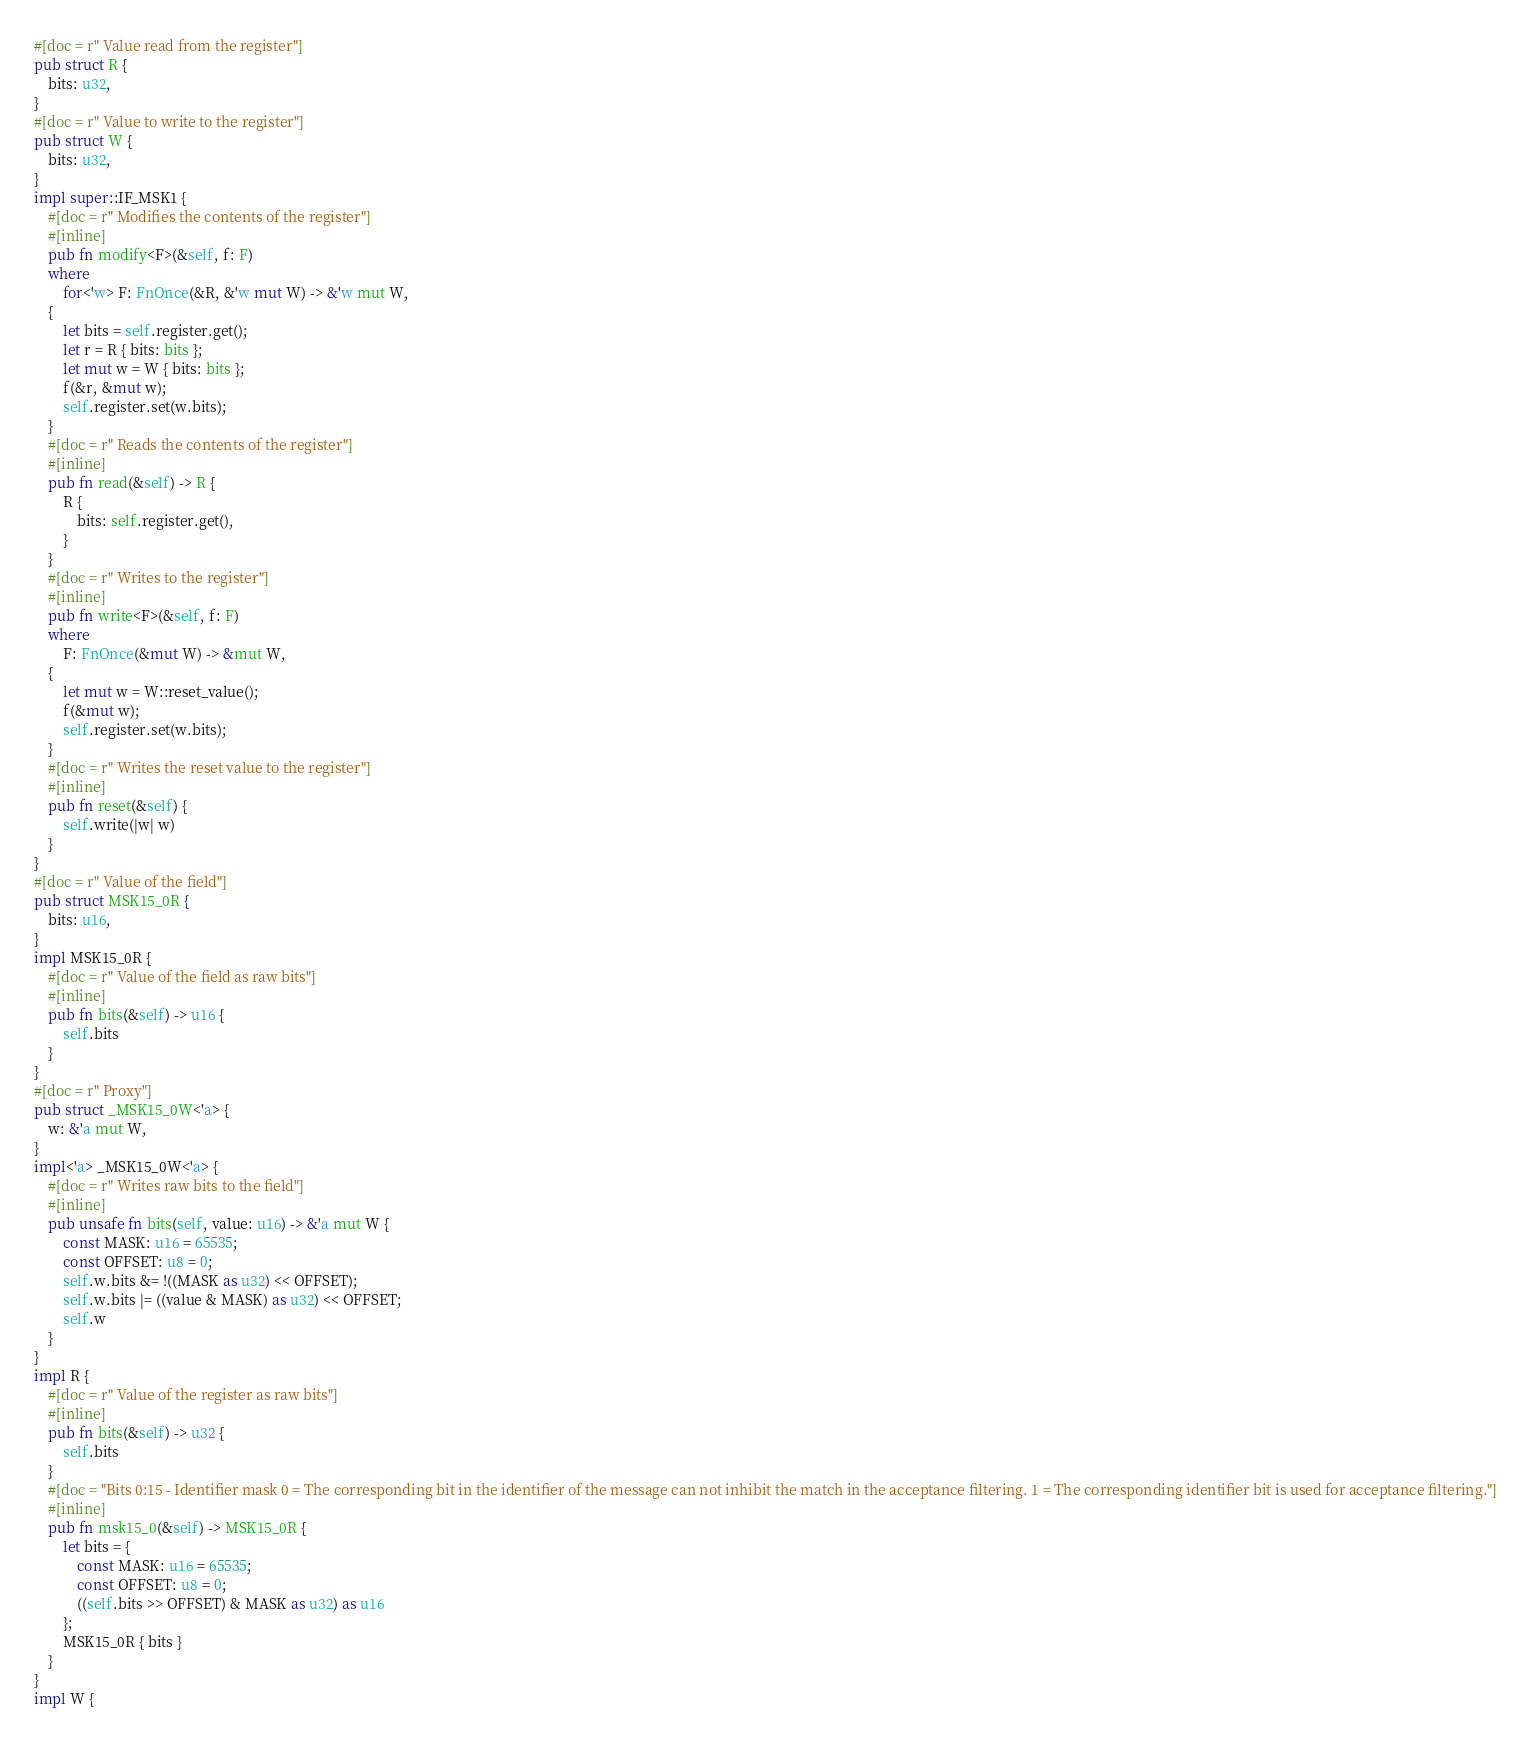Convert code to text. <code><loc_0><loc_0><loc_500><loc_500><_Rust_>#[doc = r" Value read from the register"]
pub struct R {
    bits: u32,
}
#[doc = r" Value to write to the register"]
pub struct W {
    bits: u32,
}
impl super::IF_MSK1 {
    #[doc = r" Modifies the contents of the register"]
    #[inline]
    pub fn modify<F>(&self, f: F)
    where
        for<'w> F: FnOnce(&R, &'w mut W) -> &'w mut W,
    {
        let bits = self.register.get();
        let r = R { bits: bits };
        let mut w = W { bits: bits };
        f(&r, &mut w);
        self.register.set(w.bits);
    }
    #[doc = r" Reads the contents of the register"]
    #[inline]
    pub fn read(&self) -> R {
        R {
            bits: self.register.get(),
        }
    }
    #[doc = r" Writes to the register"]
    #[inline]
    pub fn write<F>(&self, f: F)
    where
        F: FnOnce(&mut W) -> &mut W,
    {
        let mut w = W::reset_value();
        f(&mut w);
        self.register.set(w.bits);
    }
    #[doc = r" Writes the reset value to the register"]
    #[inline]
    pub fn reset(&self) {
        self.write(|w| w)
    }
}
#[doc = r" Value of the field"]
pub struct MSK15_0R {
    bits: u16,
}
impl MSK15_0R {
    #[doc = r" Value of the field as raw bits"]
    #[inline]
    pub fn bits(&self) -> u16 {
        self.bits
    }
}
#[doc = r" Proxy"]
pub struct _MSK15_0W<'a> {
    w: &'a mut W,
}
impl<'a> _MSK15_0W<'a> {
    #[doc = r" Writes raw bits to the field"]
    #[inline]
    pub unsafe fn bits(self, value: u16) -> &'a mut W {
        const MASK: u16 = 65535;
        const OFFSET: u8 = 0;
        self.w.bits &= !((MASK as u32) << OFFSET);
        self.w.bits |= ((value & MASK) as u32) << OFFSET;
        self.w
    }
}
impl R {
    #[doc = r" Value of the register as raw bits"]
    #[inline]
    pub fn bits(&self) -> u32 {
        self.bits
    }
    #[doc = "Bits 0:15 - Identifier mask 0 = The corresponding bit in the identifier of the message can not inhibit the match in the acceptance filtering. 1 = The corresponding identifier bit is used for acceptance filtering."]
    #[inline]
    pub fn msk15_0(&self) -> MSK15_0R {
        let bits = {
            const MASK: u16 = 65535;
            const OFFSET: u8 = 0;
            ((self.bits >> OFFSET) & MASK as u32) as u16
        };
        MSK15_0R { bits }
    }
}
impl W {</code> 